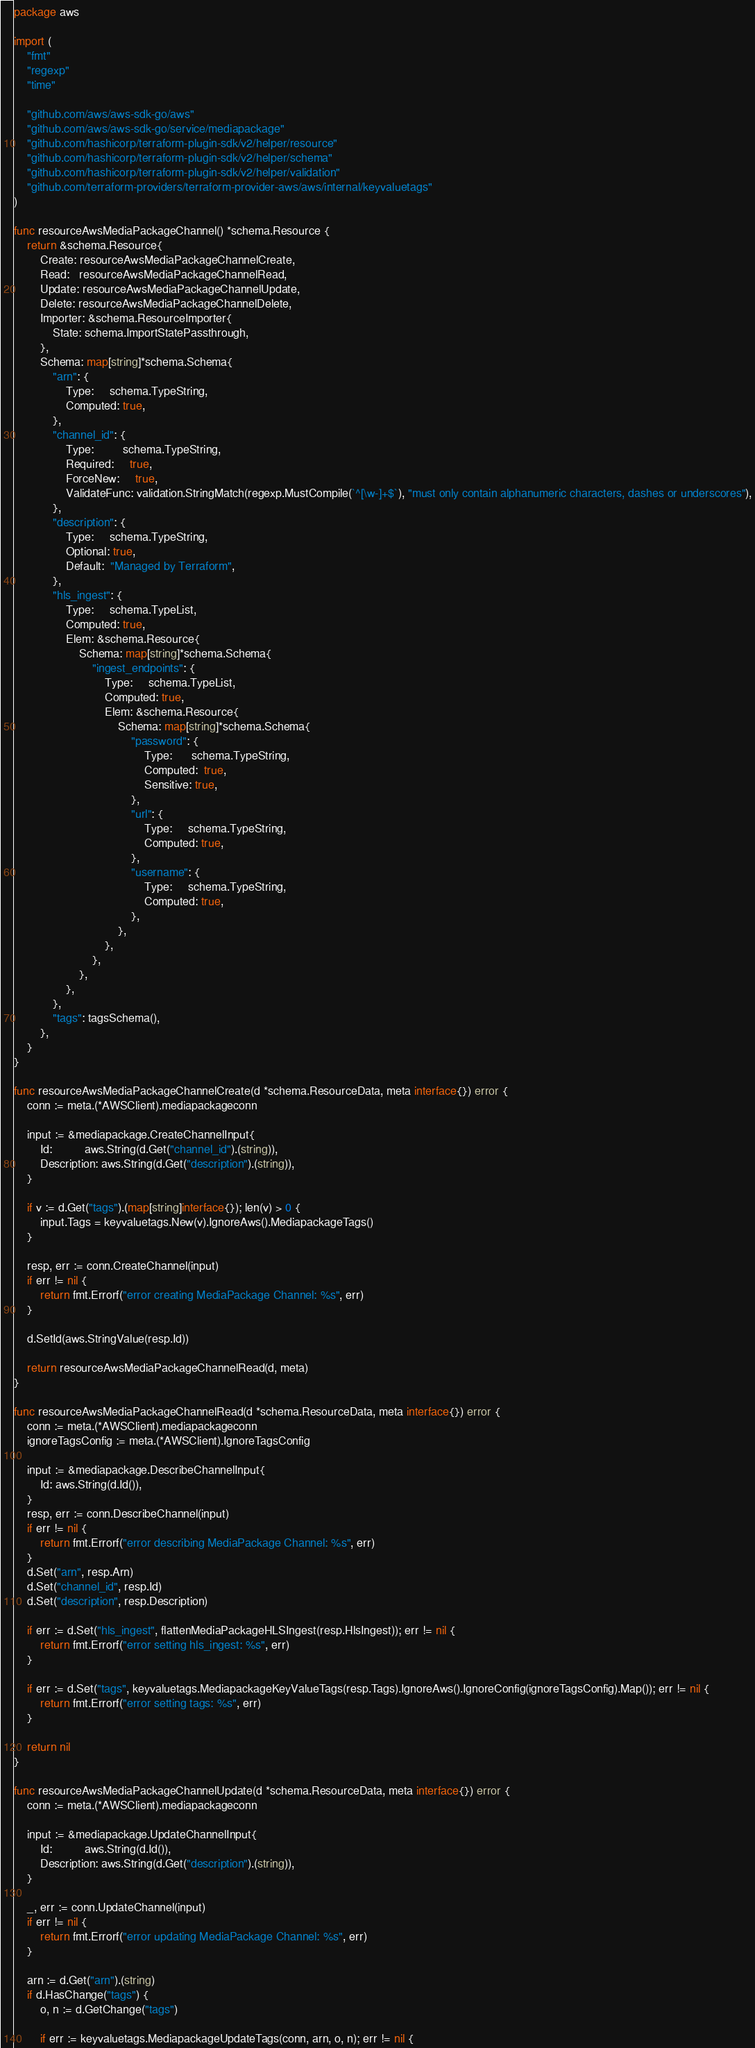<code> <loc_0><loc_0><loc_500><loc_500><_Go_>package aws

import (
	"fmt"
	"regexp"
	"time"

	"github.com/aws/aws-sdk-go/aws"
	"github.com/aws/aws-sdk-go/service/mediapackage"
	"github.com/hashicorp/terraform-plugin-sdk/v2/helper/resource"
	"github.com/hashicorp/terraform-plugin-sdk/v2/helper/schema"
	"github.com/hashicorp/terraform-plugin-sdk/v2/helper/validation"
	"github.com/terraform-providers/terraform-provider-aws/aws/internal/keyvaluetags"
)

func resourceAwsMediaPackageChannel() *schema.Resource {
	return &schema.Resource{
		Create: resourceAwsMediaPackageChannelCreate,
		Read:   resourceAwsMediaPackageChannelRead,
		Update: resourceAwsMediaPackageChannelUpdate,
		Delete: resourceAwsMediaPackageChannelDelete,
		Importer: &schema.ResourceImporter{
			State: schema.ImportStatePassthrough,
		},
		Schema: map[string]*schema.Schema{
			"arn": {
				Type:     schema.TypeString,
				Computed: true,
			},
			"channel_id": {
				Type:         schema.TypeString,
				Required:     true,
				ForceNew:     true,
				ValidateFunc: validation.StringMatch(regexp.MustCompile(`^[\w-]+$`), "must only contain alphanumeric characters, dashes or underscores"),
			},
			"description": {
				Type:     schema.TypeString,
				Optional: true,
				Default:  "Managed by Terraform",
			},
			"hls_ingest": {
				Type:     schema.TypeList,
				Computed: true,
				Elem: &schema.Resource{
					Schema: map[string]*schema.Schema{
						"ingest_endpoints": {
							Type:     schema.TypeList,
							Computed: true,
							Elem: &schema.Resource{
								Schema: map[string]*schema.Schema{
									"password": {
										Type:      schema.TypeString,
										Computed:  true,
										Sensitive: true,
									},
									"url": {
										Type:     schema.TypeString,
										Computed: true,
									},
									"username": {
										Type:     schema.TypeString,
										Computed: true,
									},
								},
							},
						},
					},
				},
			},
			"tags": tagsSchema(),
		},
	}
}

func resourceAwsMediaPackageChannelCreate(d *schema.ResourceData, meta interface{}) error {
	conn := meta.(*AWSClient).mediapackageconn

	input := &mediapackage.CreateChannelInput{
		Id:          aws.String(d.Get("channel_id").(string)),
		Description: aws.String(d.Get("description").(string)),
	}

	if v := d.Get("tags").(map[string]interface{}); len(v) > 0 {
		input.Tags = keyvaluetags.New(v).IgnoreAws().MediapackageTags()
	}

	resp, err := conn.CreateChannel(input)
	if err != nil {
		return fmt.Errorf("error creating MediaPackage Channel: %s", err)
	}

	d.SetId(aws.StringValue(resp.Id))

	return resourceAwsMediaPackageChannelRead(d, meta)
}

func resourceAwsMediaPackageChannelRead(d *schema.ResourceData, meta interface{}) error {
	conn := meta.(*AWSClient).mediapackageconn
	ignoreTagsConfig := meta.(*AWSClient).IgnoreTagsConfig

	input := &mediapackage.DescribeChannelInput{
		Id: aws.String(d.Id()),
	}
	resp, err := conn.DescribeChannel(input)
	if err != nil {
		return fmt.Errorf("error describing MediaPackage Channel: %s", err)
	}
	d.Set("arn", resp.Arn)
	d.Set("channel_id", resp.Id)
	d.Set("description", resp.Description)

	if err := d.Set("hls_ingest", flattenMediaPackageHLSIngest(resp.HlsIngest)); err != nil {
		return fmt.Errorf("error setting hls_ingest: %s", err)
	}

	if err := d.Set("tags", keyvaluetags.MediapackageKeyValueTags(resp.Tags).IgnoreAws().IgnoreConfig(ignoreTagsConfig).Map()); err != nil {
		return fmt.Errorf("error setting tags: %s", err)
	}

	return nil
}

func resourceAwsMediaPackageChannelUpdate(d *schema.ResourceData, meta interface{}) error {
	conn := meta.(*AWSClient).mediapackageconn

	input := &mediapackage.UpdateChannelInput{
		Id:          aws.String(d.Id()),
		Description: aws.String(d.Get("description").(string)),
	}

	_, err := conn.UpdateChannel(input)
	if err != nil {
		return fmt.Errorf("error updating MediaPackage Channel: %s", err)
	}

	arn := d.Get("arn").(string)
	if d.HasChange("tags") {
		o, n := d.GetChange("tags")

		if err := keyvaluetags.MediapackageUpdateTags(conn, arn, o, n); err != nil {</code> 